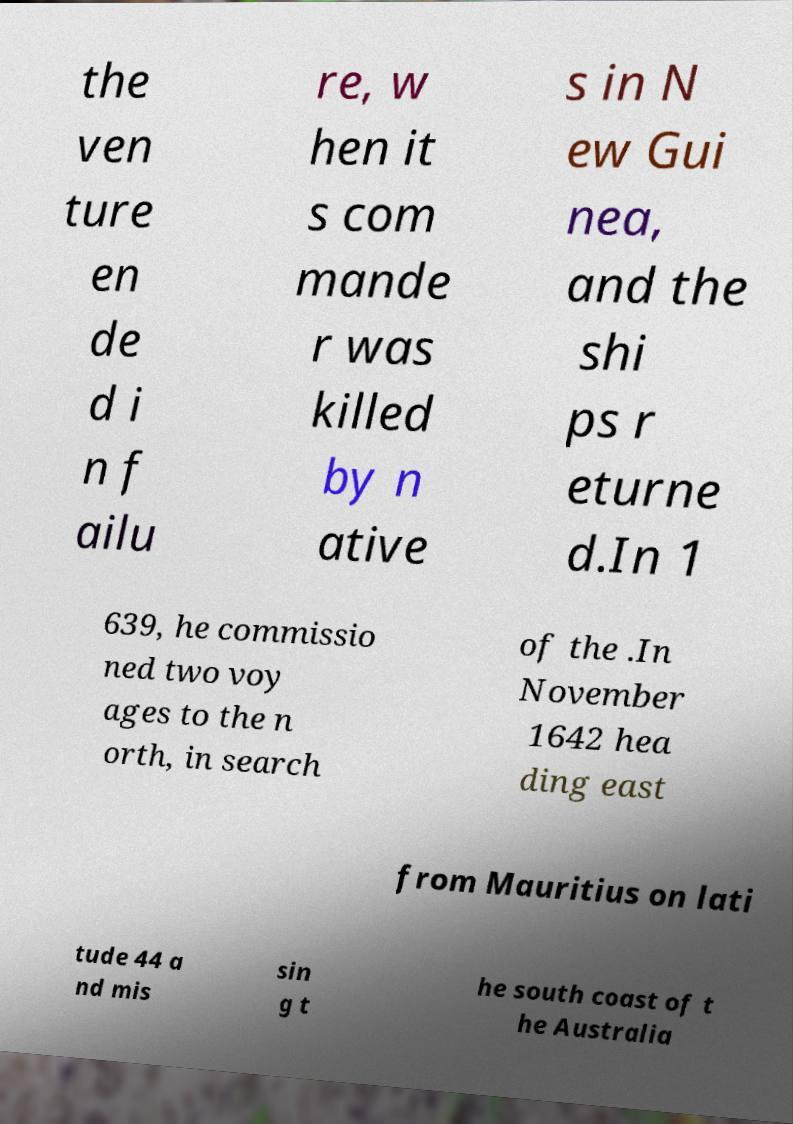Please identify and transcribe the text found in this image. the ven ture en de d i n f ailu re, w hen it s com mande r was killed by n ative s in N ew Gui nea, and the shi ps r eturne d.In 1 639, he commissio ned two voy ages to the n orth, in search of the .In November 1642 hea ding east from Mauritius on lati tude 44 a nd mis sin g t he south coast of t he Australia 